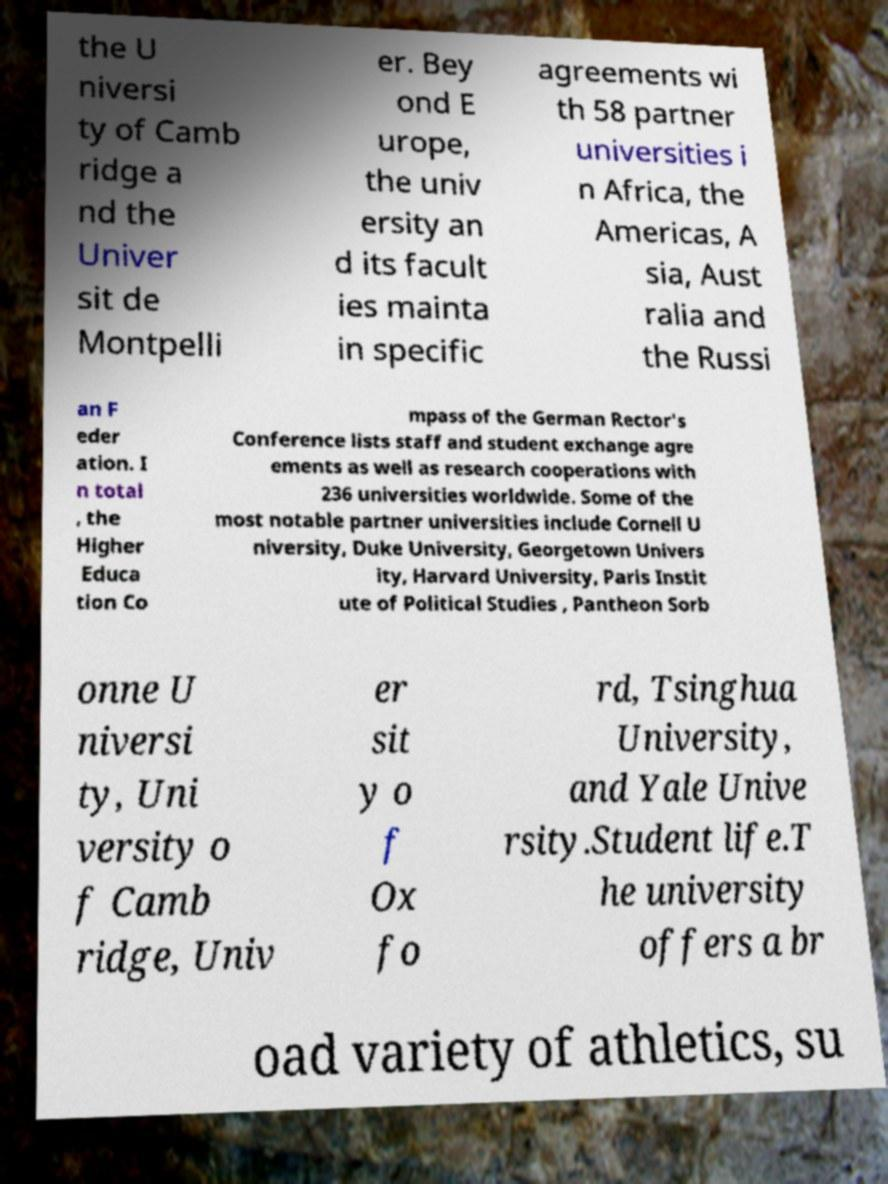Please identify and transcribe the text found in this image. the U niversi ty of Camb ridge a nd the Univer sit de Montpelli er. Bey ond E urope, the univ ersity an d its facult ies mainta in specific agreements wi th 58 partner universities i n Africa, the Americas, A sia, Aust ralia and the Russi an F eder ation. I n total , the Higher Educa tion Co mpass of the German Rector's Conference lists staff and student exchange agre ements as well as research cooperations with 236 universities worldwide. Some of the most notable partner universities include Cornell U niversity, Duke University, Georgetown Univers ity, Harvard University, Paris Instit ute of Political Studies , Pantheon Sorb onne U niversi ty, Uni versity o f Camb ridge, Univ er sit y o f Ox fo rd, Tsinghua University, and Yale Unive rsity.Student life.T he university offers a br oad variety of athletics, su 